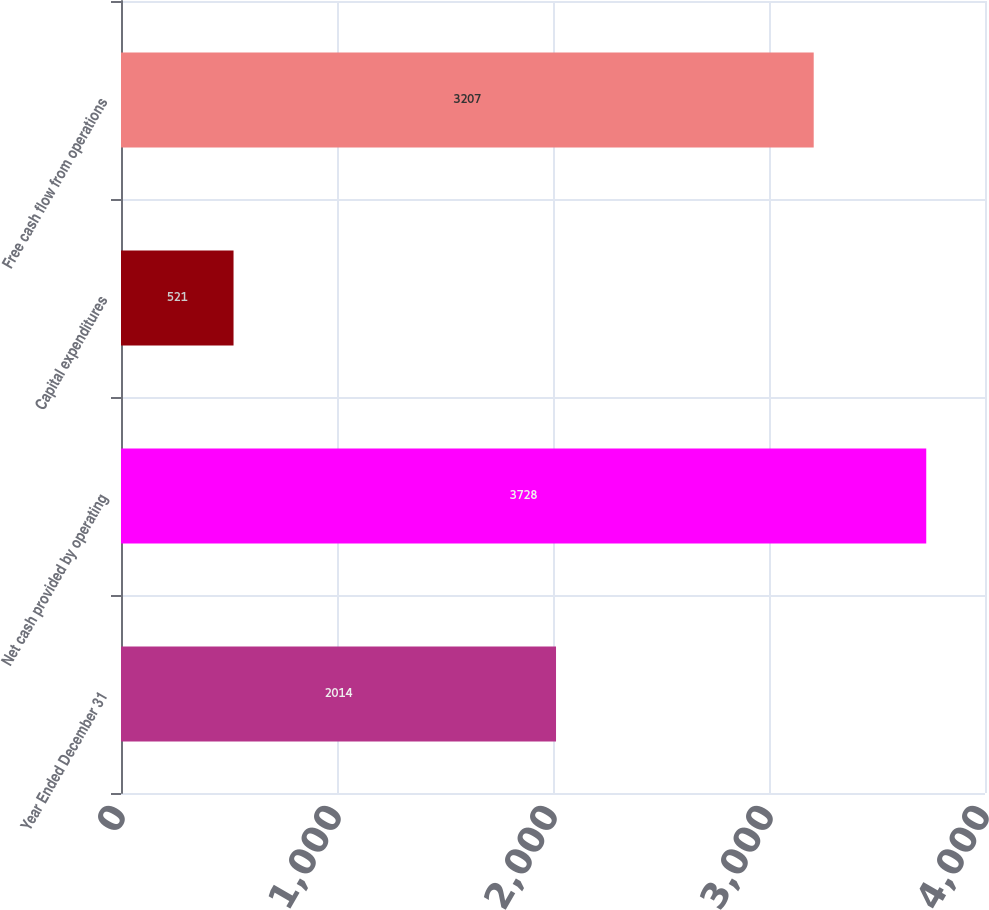<chart> <loc_0><loc_0><loc_500><loc_500><bar_chart><fcel>Year Ended December 31<fcel>Net cash provided by operating<fcel>Capital expenditures<fcel>Free cash flow from operations<nl><fcel>2014<fcel>3728<fcel>521<fcel>3207<nl></chart> 